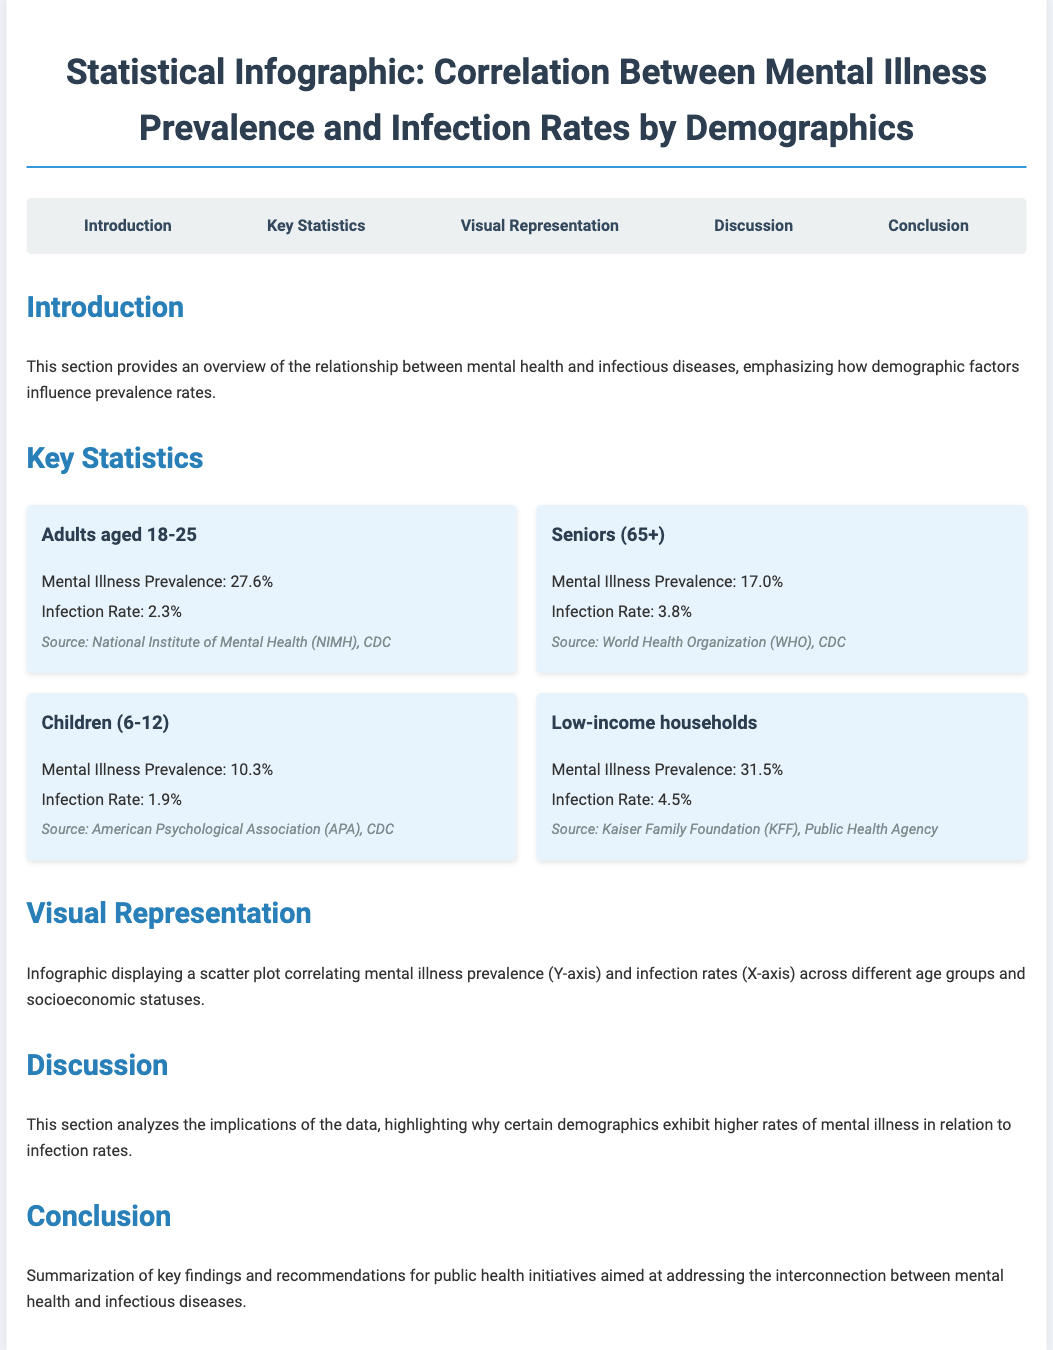What is the mental illness prevalence for adults aged 18-25? The document states that the mental illness prevalence for adults aged 18-25 is 27.6%.
Answer: 27.6% What is the infection rate for children aged 6-12? According to the document, the infection rate for children ages 6-12 is 1.9%.
Answer: 1.9% What is the mental illness prevalence for low-income households? The document lists the mental illness prevalence for low-income households as 31.5%.
Answer: 31.5% What is the source for infection rates in seniors (65+)? The document attributes the source for infection rates in seniors (65+) to the World Health Organization (WHO) and CDC.
Answer: World Health Organization (WHO), CDC Which demographic has the highest infection rate? The document indicates that low-income households have the highest infection rate at 4.5%.
Answer: 4.5% What is the primary focus of the introduction section? The introduction provides an overview of the relationship between mental health and infectious diseases, particularly how demographic factors influence prevalence rates.
Answer: Overview of the relationship between mental health and infectious diseases What type of visual representation is included in the infographic? The document mentions a scatter plot correlating mental illness prevalence and infection rates.
Answer: Scatter plot What section follows the key statistics section? According to the document structure, the section that follows key statistics is visual representation.
Answer: Visual Representation What is the concluding theme of the document? The conclusion summarizes key findings and recommendations for public health initiatives.
Answer: Key findings and recommendations 